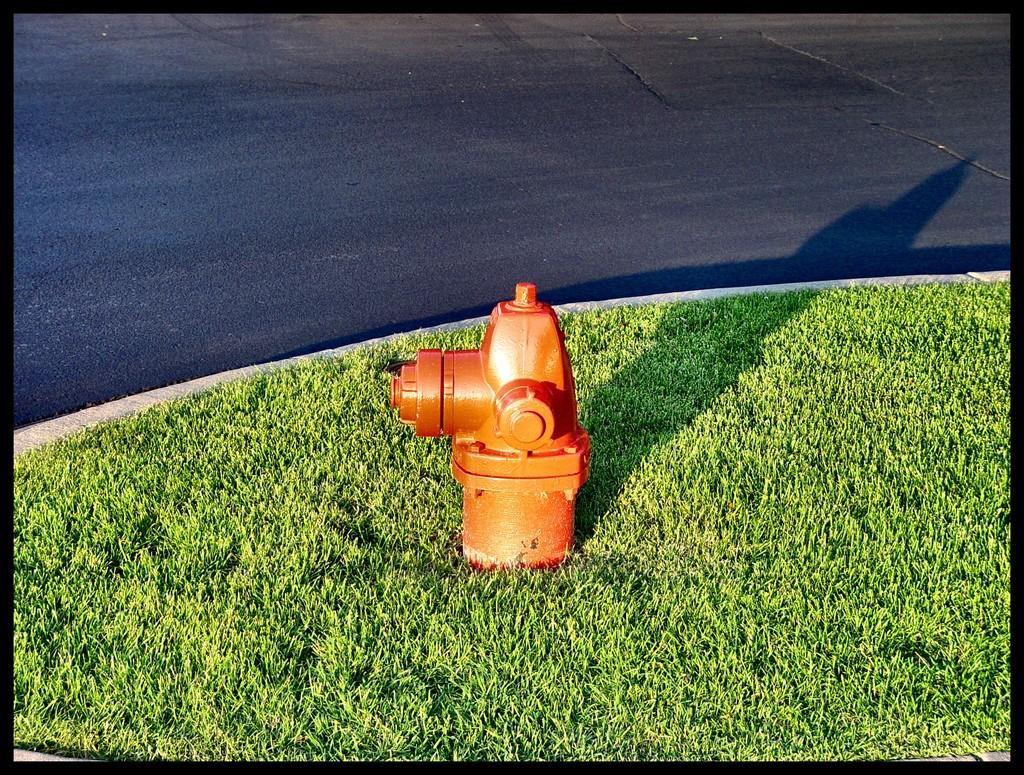What object is the main subject of the image? There is a fire hydrant in the image. What is the color of the fire hydrant? The fire hydrant is orange in color. Where is the fire hydrant located? The fire hydrant is on the grass. What else can be seen in the image besides the fire hydrant? There is a road visible in the image. Can you describe the shade of the man standing next to the fire hydrant in the image? There is no man present in the image; it only features a fire hydrant on the grass and a road visible in the background. 